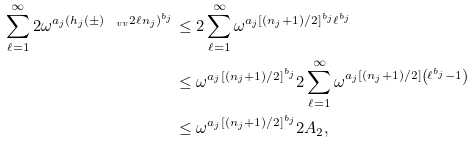Convert formula to latex. <formula><loc_0><loc_0><loc_500><loc_500>\sum _ { \ell = 1 } ^ { \infty } 2 \omega ^ { a _ { j } ( h _ { j } ( \pm ) _ { \ v v } 2 \ell n _ { j } ) ^ { b _ { j } } } & \leq 2 \sum _ { \ell = 1 } ^ { \infty } \omega ^ { a _ { j } [ ( n _ { j } + 1 ) / 2 ] ^ { b _ { j } } \ell ^ { b _ { j } } } \\ & \leq \omega ^ { a _ { j } [ ( n _ { j } + 1 ) / 2 ] ^ { b _ { j } } } 2 \sum _ { \ell = 1 } ^ { \infty } \omega ^ { a _ { j } [ ( n _ { j } + 1 ) / 2 ] \left ( \ell ^ { b _ { j } } - 1 \right ) } \\ & \leq \omega ^ { a _ { j } [ ( n _ { j } + 1 ) / 2 ] ^ { b _ { j } } } 2 A _ { 2 } ,</formula> 